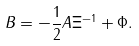<formula> <loc_0><loc_0><loc_500><loc_500>B = - \frac { 1 } { 2 } A \Xi ^ { - 1 } + \Phi .</formula> 